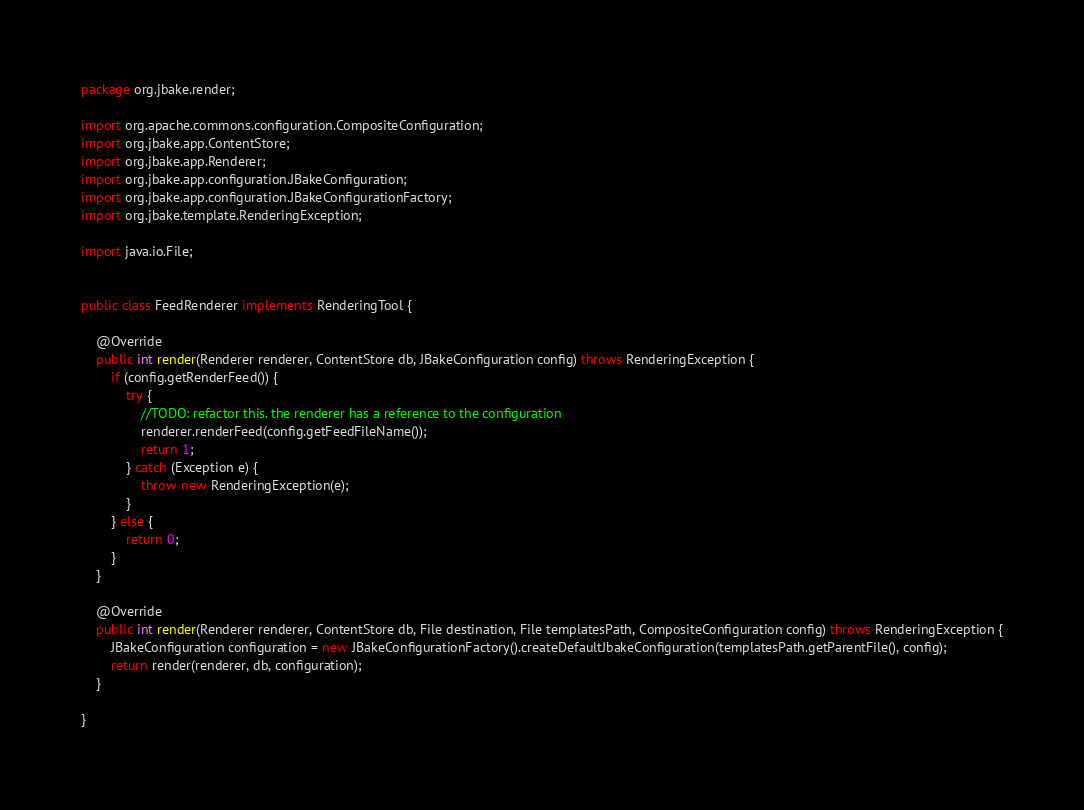<code> <loc_0><loc_0><loc_500><loc_500><_Java_>package org.jbake.render;

import org.apache.commons.configuration.CompositeConfiguration;
import org.jbake.app.ContentStore;
import org.jbake.app.Renderer;
import org.jbake.app.configuration.JBakeConfiguration;
import org.jbake.app.configuration.JBakeConfigurationFactory;
import org.jbake.template.RenderingException;

import java.io.File;


public class FeedRenderer implements RenderingTool {

    @Override
    public int render(Renderer renderer, ContentStore db, JBakeConfiguration config) throws RenderingException {
        if (config.getRenderFeed()) {
            try {
                //TODO: refactor this. the renderer has a reference to the configuration
                renderer.renderFeed(config.getFeedFileName());
                return 1;
            } catch (Exception e) {
                throw new RenderingException(e);
            }
        } else {
            return 0;
        }
    }

    @Override
    public int render(Renderer renderer, ContentStore db, File destination, File templatesPath, CompositeConfiguration config) throws RenderingException {
        JBakeConfiguration configuration = new JBakeConfigurationFactory().createDefaultJbakeConfiguration(templatesPath.getParentFile(), config);
        return render(renderer, db, configuration);
    }

}
</code> 